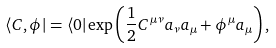<formula> <loc_0><loc_0><loc_500><loc_500>\langle { C , \phi } | = \langle { 0 } | \exp \left ( { \frac { 1 } { 2 } } C ^ { \mu \nu } a _ { \nu } a _ { \mu } + \phi ^ { \mu } a _ { \mu } \right ) ,</formula> 